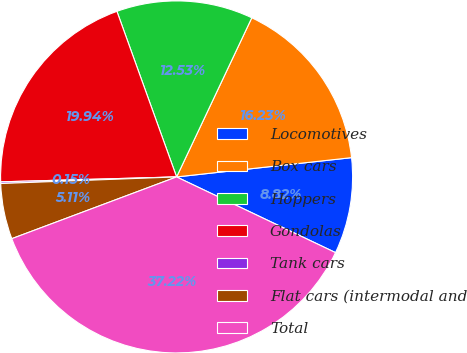<chart> <loc_0><loc_0><loc_500><loc_500><pie_chart><fcel>Locomotives<fcel>Box cars<fcel>Hoppers<fcel>Gondolas<fcel>Tank cars<fcel>Flat cars (intermodal and<fcel>Total<nl><fcel>8.82%<fcel>16.23%<fcel>12.53%<fcel>19.94%<fcel>0.15%<fcel>5.11%<fcel>37.22%<nl></chart> 